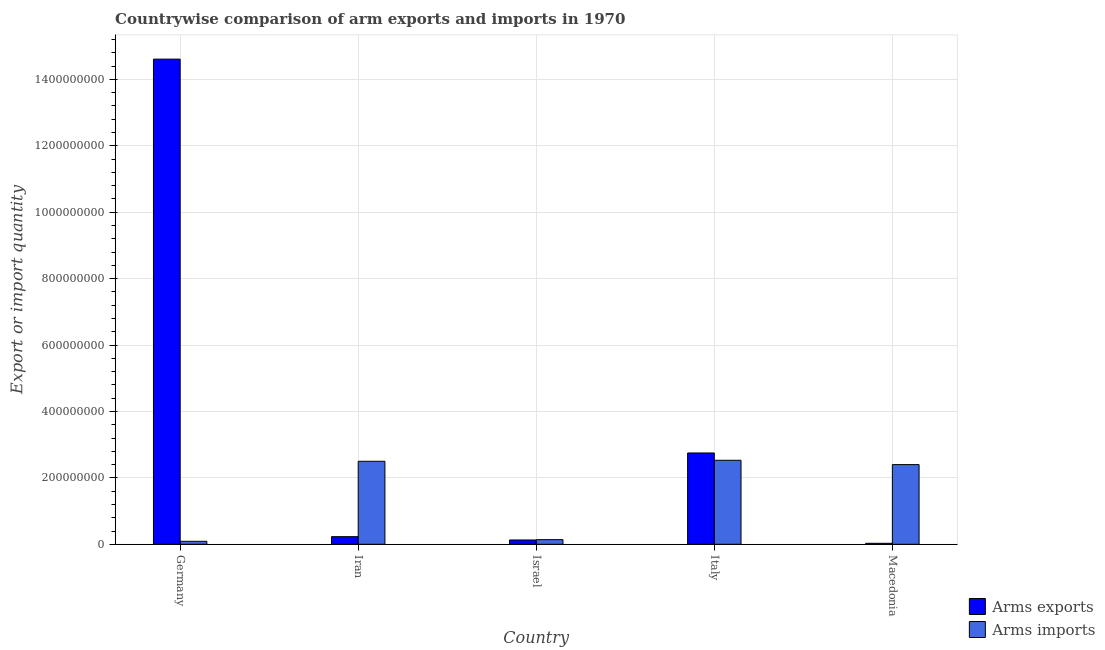How many bars are there on the 1st tick from the left?
Your answer should be compact. 2. What is the label of the 2nd group of bars from the left?
Provide a succinct answer. Iran. What is the arms imports in Germany?
Your response must be concise. 9.00e+06. Across all countries, what is the maximum arms imports?
Provide a short and direct response. 2.53e+08. Across all countries, what is the minimum arms exports?
Your answer should be very brief. 3.00e+06. What is the total arms imports in the graph?
Keep it short and to the point. 7.66e+08. What is the difference between the arms imports in Israel and that in Italy?
Give a very brief answer. -2.39e+08. What is the difference between the arms exports in Italy and the arms imports in Israel?
Provide a short and direct response. 2.61e+08. What is the average arms exports per country?
Offer a very short reply. 3.55e+08. What is the difference between the arms exports and arms imports in Germany?
Make the answer very short. 1.45e+09. In how many countries, is the arms imports greater than 600000000 ?
Give a very brief answer. 0. What is the ratio of the arms exports in Israel to that in Italy?
Ensure brevity in your answer.  0.05. Is the arms imports in Germany less than that in Israel?
Provide a succinct answer. Yes. Is the difference between the arms imports in Israel and Italy greater than the difference between the arms exports in Israel and Italy?
Offer a terse response. Yes. What is the difference between the highest and the second highest arms exports?
Keep it short and to the point. 1.19e+09. What is the difference between the highest and the lowest arms imports?
Provide a succinct answer. 2.44e+08. What does the 2nd bar from the left in Iran represents?
Keep it short and to the point. Arms imports. What does the 1st bar from the right in Iran represents?
Keep it short and to the point. Arms imports. Are all the bars in the graph horizontal?
Provide a short and direct response. No. How many countries are there in the graph?
Your response must be concise. 5. Does the graph contain any zero values?
Your response must be concise. No. Does the graph contain grids?
Provide a short and direct response. Yes. How many legend labels are there?
Ensure brevity in your answer.  2. How are the legend labels stacked?
Offer a very short reply. Vertical. What is the title of the graph?
Your answer should be compact. Countrywise comparison of arm exports and imports in 1970. What is the label or title of the X-axis?
Offer a terse response. Country. What is the label or title of the Y-axis?
Offer a terse response. Export or import quantity. What is the Export or import quantity in Arms exports in Germany?
Keep it short and to the point. 1.46e+09. What is the Export or import quantity of Arms imports in Germany?
Make the answer very short. 9.00e+06. What is the Export or import quantity in Arms exports in Iran?
Provide a succinct answer. 2.30e+07. What is the Export or import quantity in Arms imports in Iran?
Provide a succinct answer. 2.50e+08. What is the Export or import quantity of Arms exports in Israel?
Keep it short and to the point. 1.30e+07. What is the Export or import quantity in Arms imports in Israel?
Provide a succinct answer. 1.40e+07. What is the Export or import quantity of Arms exports in Italy?
Your answer should be very brief. 2.75e+08. What is the Export or import quantity of Arms imports in Italy?
Your answer should be very brief. 2.53e+08. What is the Export or import quantity in Arms imports in Macedonia?
Make the answer very short. 2.40e+08. Across all countries, what is the maximum Export or import quantity in Arms exports?
Provide a succinct answer. 1.46e+09. Across all countries, what is the maximum Export or import quantity of Arms imports?
Provide a short and direct response. 2.53e+08. Across all countries, what is the minimum Export or import quantity in Arms exports?
Offer a very short reply. 3.00e+06. Across all countries, what is the minimum Export or import quantity of Arms imports?
Your response must be concise. 9.00e+06. What is the total Export or import quantity in Arms exports in the graph?
Your answer should be very brief. 1.78e+09. What is the total Export or import quantity of Arms imports in the graph?
Give a very brief answer. 7.66e+08. What is the difference between the Export or import quantity of Arms exports in Germany and that in Iran?
Make the answer very short. 1.44e+09. What is the difference between the Export or import quantity of Arms imports in Germany and that in Iran?
Ensure brevity in your answer.  -2.41e+08. What is the difference between the Export or import quantity in Arms exports in Germany and that in Israel?
Offer a terse response. 1.45e+09. What is the difference between the Export or import quantity of Arms imports in Germany and that in Israel?
Provide a short and direct response. -5.00e+06. What is the difference between the Export or import quantity in Arms exports in Germany and that in Italy?
Offer a very short reply. 1.19e+09. What is the difference between the Export or import quantity of Arms imports in Germany and that in Italy?
Your response must be concise. -2.44e+08. What is the difference between the Export or import quantity in Arms exports in Germany and that in Macedonia?
Your answer should be very brief. 1.46e+09. What is the difference between the Export or import quantity in Arms imports in Germany and that in Macedonia?
Your answer should be very brief. -2.31e+08. What is the difference between the Export or import quantity of Arms imports in Iran and that in Israel?
Provide a succinct answer. 2.36e+08. What is the difference between the Export or import quantity in Arms exports in Iran and that in Italy?
Offer a terse response. -2.52e+08. What is the difference between the Export or import quantity of Arms imports in Iran and that in Italy?
Your answer should be compact. -3.00e+06. What is the difference between the Export or import quantity of Arms exports in Iran and that in Macedonia?
Provide a short and direct response. 2.00e+07. What is the difference between the Export or import quantity of Arms imports in Iran and that in Macedonia?
Provide a succinct answer. 1.00e+07. What is the difference between the Export or import quantity in Arms exports in Israel and that in Italy?
Your answer should be very brief. -2.62e+08. What is the difference between the Export or import quantity in Arms imports in Israel and that in Italy?
Provide a short and direct response. -2.39e+08. What is the difference between the Export or import quantity in Arms imports in Israel and that in Macedonia?
Ensure brevity in your answer.  -2.26e+08. What is the difference between the Export or import quantity in Arms exports in Italy and that in Macedonia?
Give a very brief answer. 2.72e+08. What is the difference between the Export or import quantity of Arms imports in Italy and that in Macedonia?
Keep it short and to the point. 1.30e+07. What is the difference between the Export or import quantity of Arms exports in Germany and the Export or import quantity of Arms imports in Iran?
Keep it short and to the point. 1.21e+09. What is the difference between the Export or import quantity in Arms exports in Germany and the Export or import quantity in Arms imports in Israel?
Your answer should be very brief. 1.45e+09. What is the difference between the Export or import quantity in Arms exports in Germany and the Export or import quantity in Arms imports in Italy?
Make the answer very short. 1.21e+09. What is the difference between the Export or import quantity of Arms exports in Germany and the Export or import quantity of Arms imports in Macedonia?
Make the answer very short. 1.22e+09. What is the difference between the Export or import quantity in Arms exports in Iran and the Export or import quantity in Arms imports in Israel?
Your response must be concise. 9.00e+06. What is the difference between the Export or import quantity of Arms exports in Iran and the Export or import quantity of Arms imports in Italy?
Offer a very short reply. -2.30e+08. What is the difference between the Export or import quantity of Arms exports in Iran and the Export or import quantity of Arms imports in Macedonia?
Your answer should be very brief. -2.17e+08. What is the difference between the Export or import quantity in Arms exports in Israel and the Export or import quantity in Arms imports in Italy?
Give a very brief answer. -2.40e+08. What is the difference between the Export or import quantity of Arms exports in Israel and the Export or import quantity of Arms imports in Macedonia?
Your response must be concise. -2.27e+08. What is the difference between the Export or import quantity in Arms exports in Italy and the Export or import quantity in Arms imports in Macedonia?
Your answer should be compact. 3.50e+07. What is the average Export or import quantity in Arms exports per country?
Your answer should be compact. 3.55e+08. What is the average Export or import quantity of Arms imports per country?
Make the answer very short. 1.53e+08. What is the difference between the Export or import quantity in Arms exports and Export or import quantity in Arms imports in Germany?
Make the answer very short. 1.45e+09. What is the difference between the Export or import quantity of Arms exports and Export or import quantity of Arms imports in Iran?
Offer a very short reply. -2.27e+08. What is the difference between the Export or import quantity of Arms exports and Export or import quantity of Arms imports in Italy?
Ensure brevity in your answer.  2.20e+07. What is the difference between the Export or import quantity in Arms exports and Export or import quantity in Arms imports in Macedonia?
Make the answer very short. -2.37e+08. What is the ratio of the Export or import quantity in Arms exports in Germany to that in Iran?
Ensure brevity in your answer.  63.52. What is the ratio of the Export or import quantity of Arms imports in Germany to that in Iran?
Your response must be concise. 0.04. What is the ratio of the Export or import quantity of Arms exports in Germany to that in Israel?
Keep it short and to the point. 112.38. What is the ratio of the Export or import quantity of Arms imports in Germany to that in Israel?
Provide a succinct answer. 0.64. What is the ratio of the Export or import quantity in Arms exports in Germany to that in Italy?
Offer a very short reply. 5.31. What is the ratio of the Export or import quantity of Arms imports in Germany to that in Italy?
Offer a very short reply. 0.04. What is the ratio of the Export or import quantity in Arms exports in Germany to that in Macedonia?
Provide a succinct answer. 487. What is the ratio of the Export or import quantity of Arms imports in Germany to that in Macedonia?
Make the answer very short. 0.04. What is the ratio of the Export or import quantity in Arms exports in Iran to that in Israel?
Give a very brief answer. 1.77. What is the ratio of the Export or import quantity of Arms imports in Iran to that in Israel?
Make the answer very short. 17.86. What is the ratio of the Export or import quantity of Arms exports in Iran to that in Italy?
Your answer should be very brief. 0.08. What is the ratio of the Export or import quantity of Arms exports in Iran to that in Macedonia?
Provide a succinct answer. 7.67. What is the ratio of the Export or import quantity in Arms imports in Iran to that in Macedonia?
Make the answer very short. 1.04. What is the ratio of the Export or import quantity in Arms exports in Israel to that in Italy?
Provide a succinct answer. 0.05. What is the ratio of the Export or import quantity of Arms imports in Israel to that in Italy?
Your response must be concise. 0.06. What is the ratio of the Export or import quantity of Arms exports in Israel to that in Macedonia?
Offer a terse response. 4.33. What is the ratio of the Export or import quantity of Arms imports in Israel to that in Macedonia?
Your answer should be compact. 0.06. What is the ratio of the Export or import quantity in Arms exports in Italy to that in Macedonia?
Your answer should be very brief. 91.67. What is the ratio of the Export or import quantity of Arms imports in Italy to that in Macedonia?
Ensure brevity in your answer.  1.05. What is the difference between the highest and the second highest Export or import quantity of Arms exports?
Your response must be concise. 1.19e+09. What is the difference between the highest and the second highest Export or import quantity in Arms imports?
Provide a succinct answer. 3.00e+06. What is the difference between the highest and the lowest Export or import quantity of Arms exports?
Provide a succinct answer. 1.46e+09. What is the difference between the highest and the lowest Export or import quantity of Arms imports?
Your answer should be very brief. 2.44e+08. 